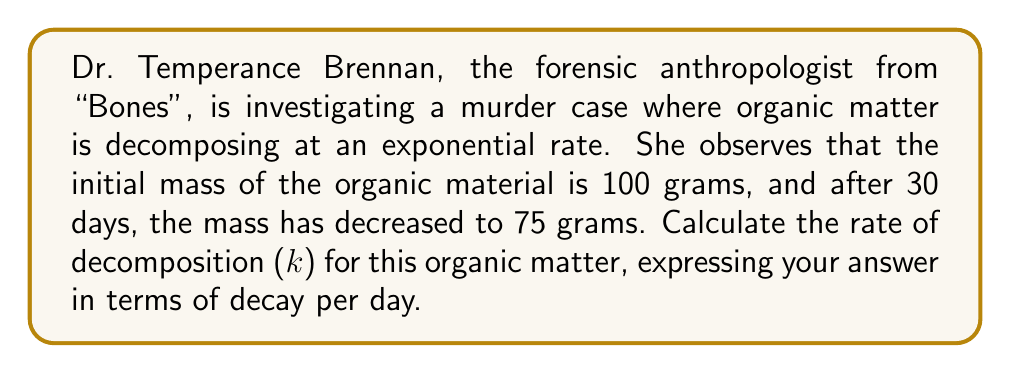Provide a solution to this math problem. To solve this problem, we'll use the exponential decay formula:

$$A(t) = A_0 e^{-kt}$$

Where:
$A(t)$ is the amount at time $t$
$A_0$ is the initial amount
$k$ is the decay rate
$t$ is the time

Given:
$A_0 = 100$ grams
$A(30) = 75$ grams
$t = 30$ days

Step 1: Substitute the known values into the formula:
$$75 = 100 e^{-k(30)}$$

Step 2: Divide both sides by 100:
$$0.75 = e^{-30k}$$

Step 3: Take the natural logarithm of both sides:
$$\ln(0.75) = -30k$$

Step 4: Solve for $k$:
$$k = -\frac{\ln(0.75)}{30}$$

Step 5: Calculate the value of $k$:
$$k = -\frac{\ln(0.75)}{30} \approx 0.009579 \text{ per day}$$

This means the organic matter is decaying at a rate of approximately 0.9579% per day.
Answer: $k \approx 0.009579 \text{ per day}$ 